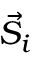Convert formula to latex. <formula><loc_0><loc_0><loc_500><loc_500>{ \vec { S } } _ { i }</formula> 